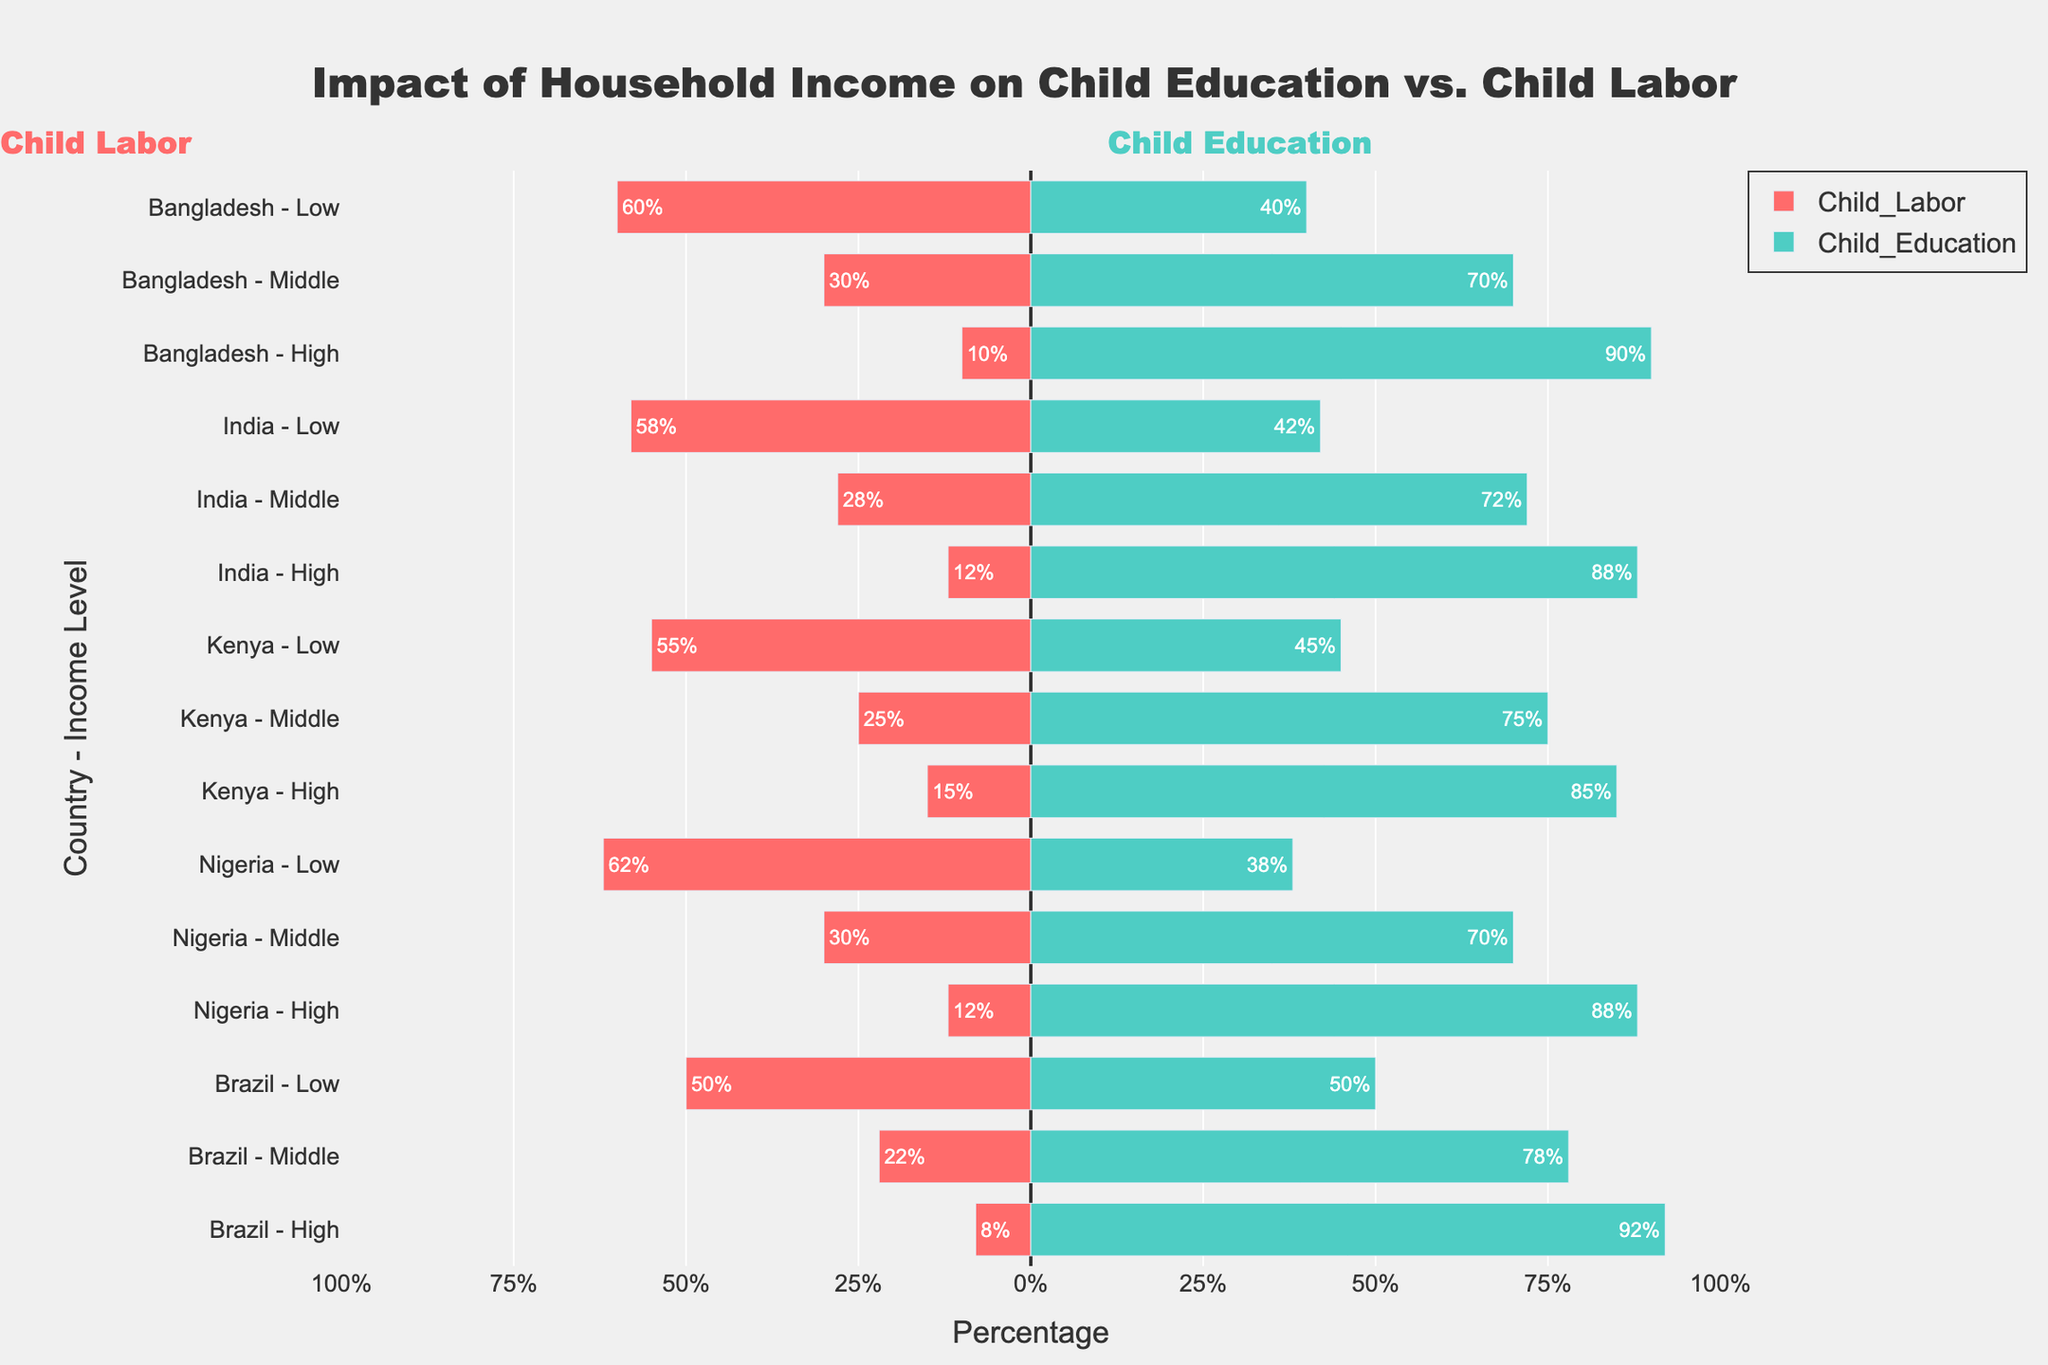What is the percentage of child labor in low-income households in Nigeria? Look for the bar representing child labor in low-income households for Nigeria. It should be colored in red and positioned on the negative side. The length indicates the percentage.
Answer: 62% Which country has the highest percentage of child education in high-income households? Compare the lengths of the green bars on the positive side representing high-income households for each country. The highest one will indicate the highest percentage.
Answer: Brazil How does the percentage of child labor in low-income households compare between India and Bangladesh? Look at the red bars representing low-income households in India and Bangladesh. India has a child labor percentage of 58% and Bangladesh 60%. Bangladesh has a slightly higher percentage of child labor.
Answer: Bangladesh has a higher percentage What is the difference in the percentage of child labor between low and high-income households in Kenya? Find the red bars for low and high-income households in Kenya. The low-income percentage is 55%, and the high-income is 15%. Subtract the high-income percentage from the low-income percentage. 55% - 15% = 40%.
Answer: 40% What is the sum of the percentages for child education in middle-income households across all countries? Add the percentages for child education in middle-income households for Bangladesh (70%), India (72%), Kenya (75%), Nigeria (70%), and Brazil (78%). 70 + 72 + 75 + 70 + 78 = 365%.
Answer: 365% Which country shows the largest disparity between child labor and child education in middle-income households? For each country, find the difference between the green and red bar lengths for middle-income households. Calculate for Bangladesh (70-30=40), India (72-28=44), Kenya (75-25=50), Nigeria (70-30=40), and Brazil (78-22=56). Brazil has the largest disparity.
Answer: Brazil In which income level does Brazil have equal percentages of child labor and child education? Look for Brazil's bars where the red and green bars have equal lengths. This occurs in the low-income level, each with 50%.
Answer: Low What are the trends observed for child labor as household income increases in India? Observe India's red bars shifting from low to high income. The percentage of child labor decreases from 58% in low-income, 28% in middle-income, to 12% in high-income households.
Answer: Decreasing What is the median percentage of child education in high-income households across all countries? List the percentages for child education in high-income households: Bangladesh (90%), India (88%), Kenya (85%), Nigeria (88%), Brazil (92%). To find the median, sort these values: 85%, 88%, 88%, 90%, 92%. The middle value is 88%.
Answer: 88% Which country has the lowest percentage of child education in low-income households? Look for the green bars representing low-income households and identify the shortest one. Brazil's bar is the shortest with a 50% for child education.
Answer: Brazil 